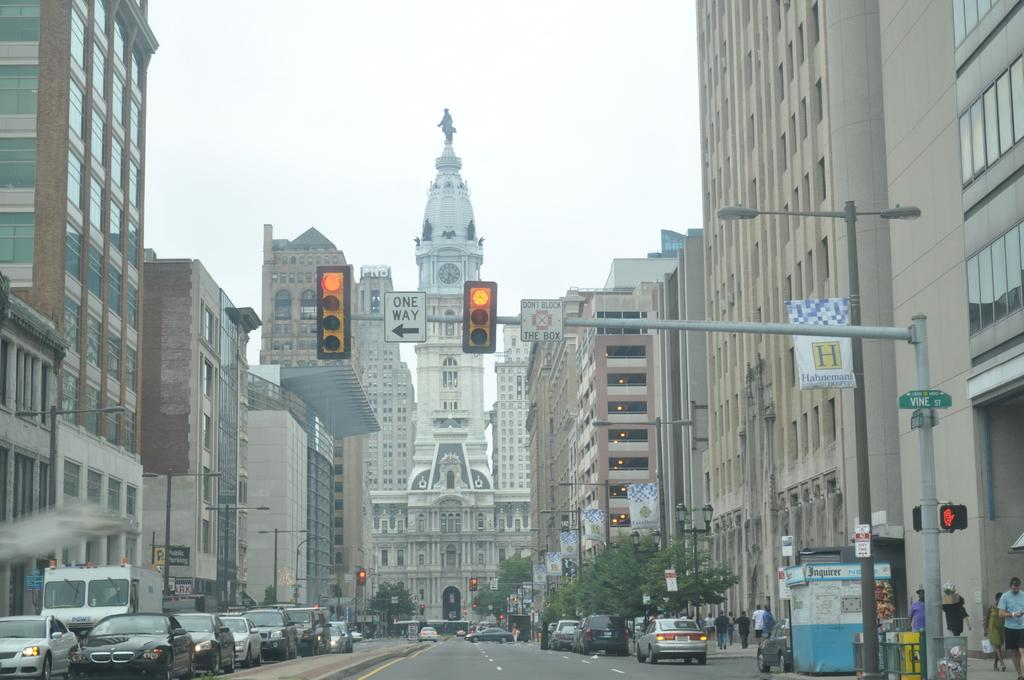<image>
Provide a brief description of the given image. a clock that is seen above a one way street 